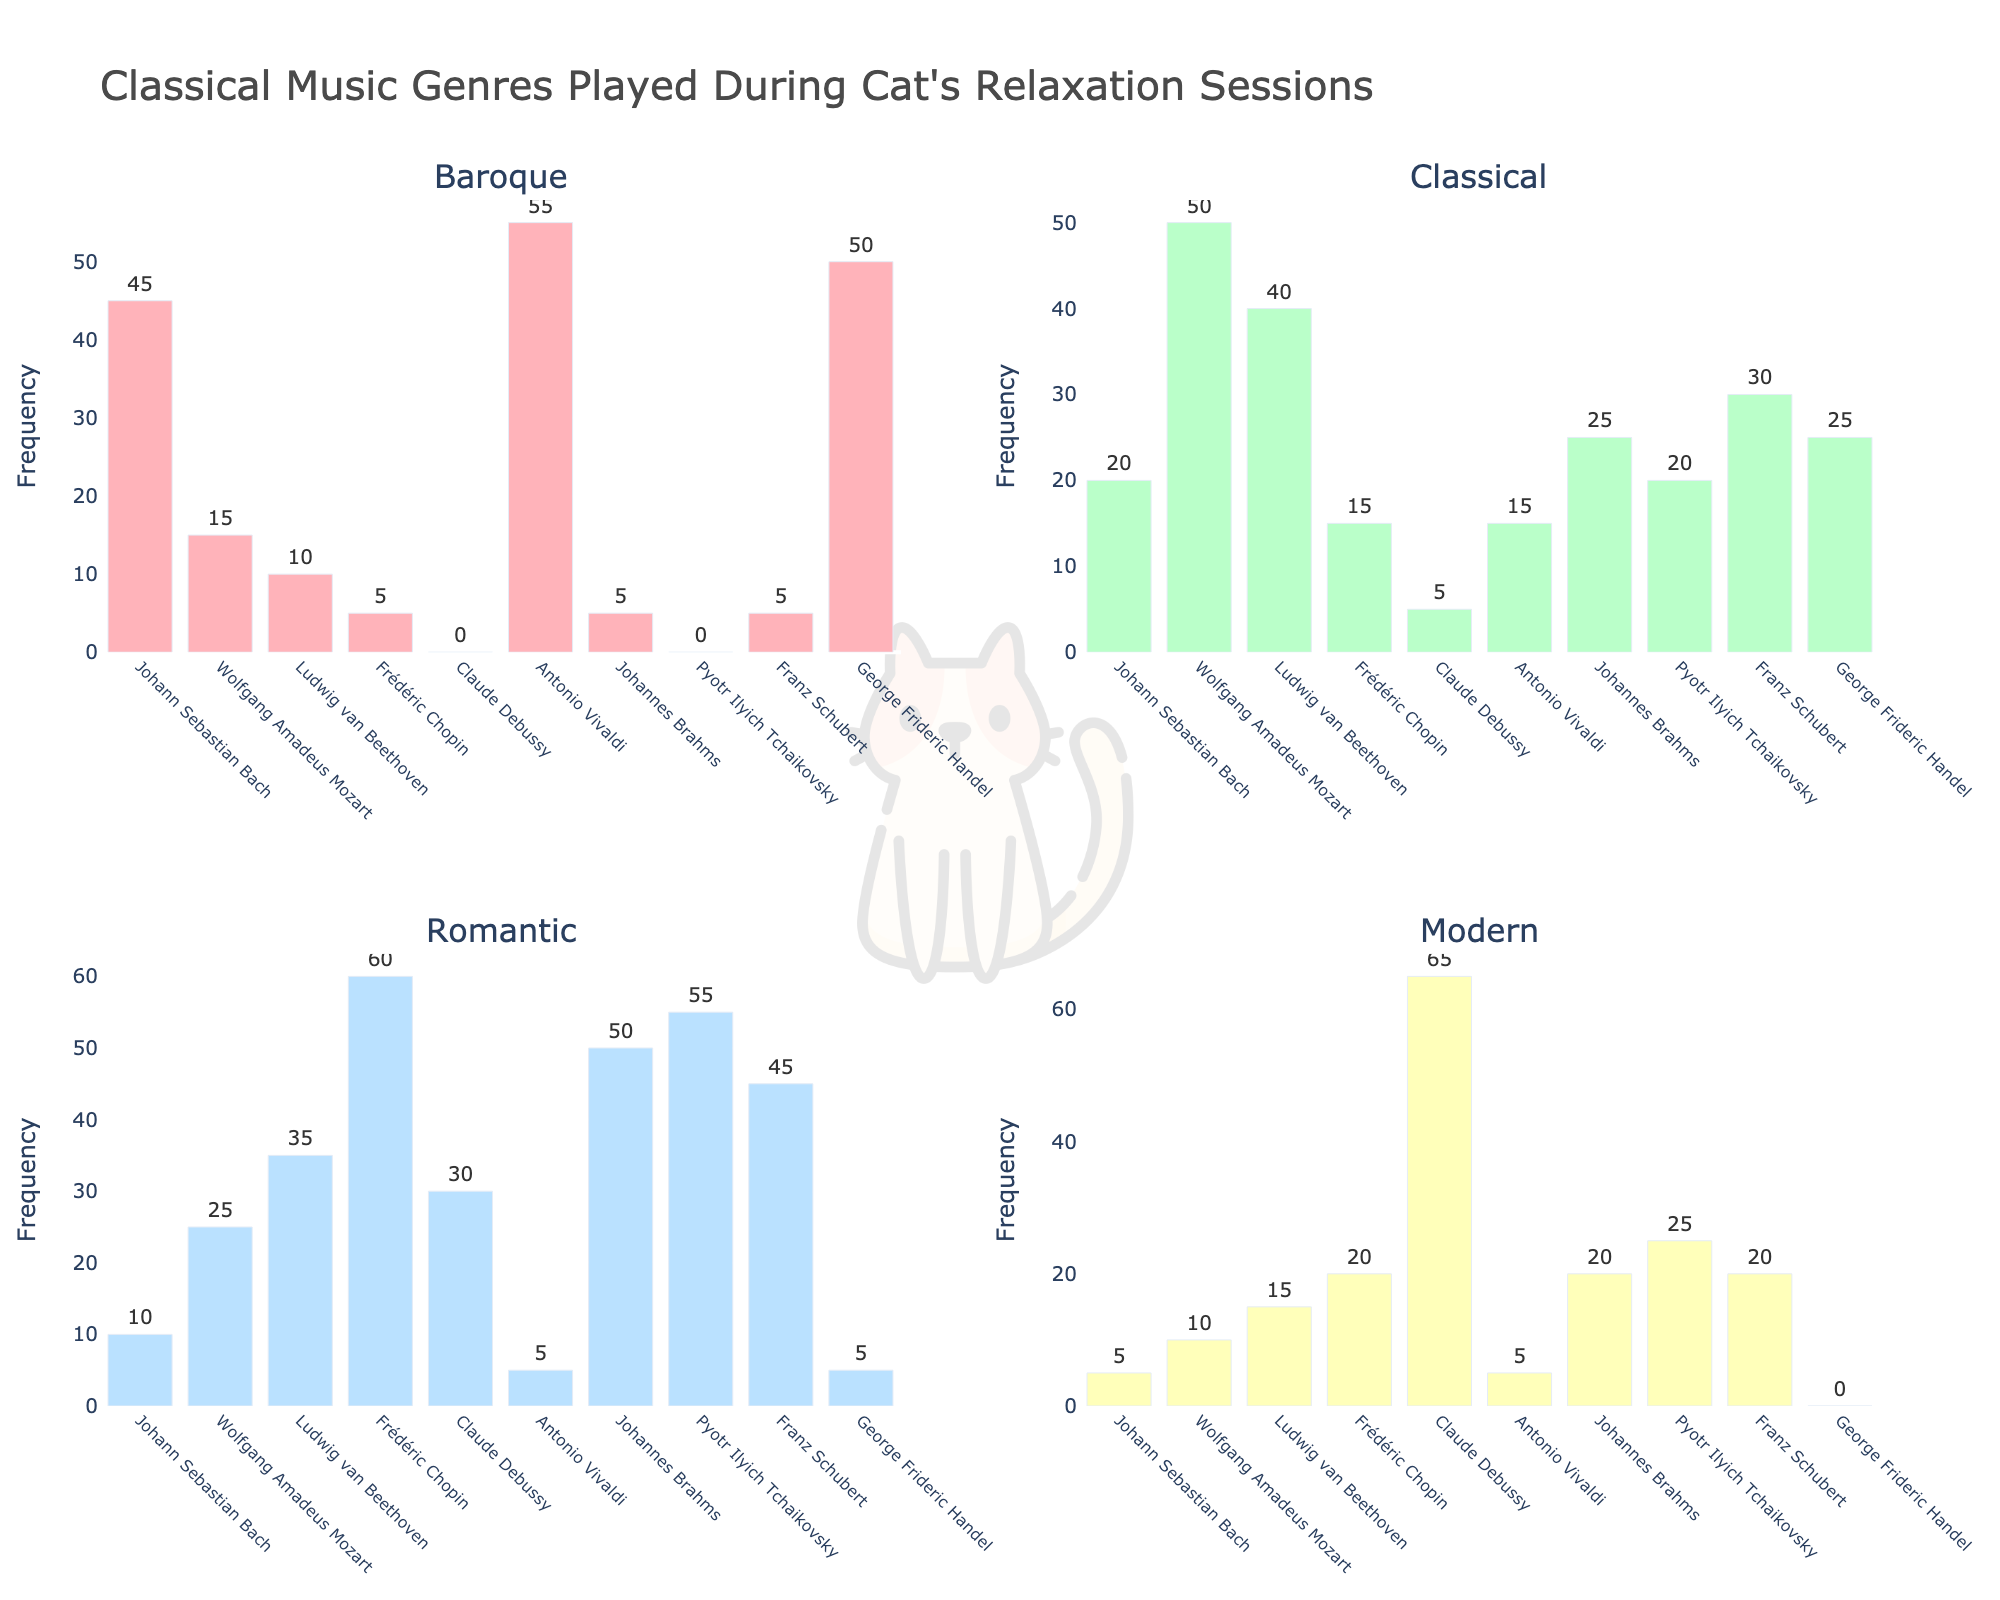Which composer has the highest frequency of Baroque genre played? In the Baroque genre subplot, Antonio Vivaldi has the highest bar, indicating the highest frequency.
Answer: Antonio Vivaldi What is the total frequency of Classical genre played across all composers? Summing the frequencies for the Classical genre subplot: 20 + 50 + 40 + 15 + 5 + 15 + 25 + 20 + 30 + 25 = 245
Answer: 245 Which genres does Ludwig van Beethoven have a higher frequency than Frédéric Chopin? Comparing the bars of Ludwig van Beethoven and Frédéric Chopin in each subplot: Ludwig van Beethoven has a higher frequency in the Baroque, Classical, and Modern genres.
Answer: Baroque, Classical, Modern Which composer has the lowest frequency of Modern genre played? In the Modern genre subplot, Johann Sebastian Bach and Antonio Vivaldi both have the lowest bar, indicating the lowest frequency.
Answer: Johann Sebastian Bach, Antonio Vivaldi For Pyotr Ilyich Tchaikovsky, how many total frequencies are played in the Romantic and Modern genres combined? Adding the frequencies for Pyotr Ilyich Tchaikovsky in the Romantic and Modern subplots: 55 + 25 = 80
Answer: 80 What is the average frequency of Romantic genre played across all composers? Summing the frequencies for the Romantic genre subplot and dividing by the number of composers (10): (10 + 25 + 35 + 60 + 30 + 5 + 50 + 55 + 45 + 5) / 10 = 32
Answer: 32 How many composers have a frequency of 0 for the Baroque genre? Observing the Baroque genre subplot, Pyotr Ilyich Tchaikovsky and Claude Debussy both have a frequency of 0, so there are 2 composers.
Answer: 2 Which genre has the largest frequency variation among composers, and which has the smallest? By visually comparing the ranges of frequencies in each subplot, the Baroque genre has the largest variation (0 to 55), and the Classical genre has the smallest variation (5 to 50).
Answer: Largest: Baroque, Smallest: Classical What is the difference in frequency of the Classical genre played between Johann Sebastian Bach and Wolfgang Amadeus Mozart? Subtracting the frequency of the Classical genre for Johann Sebastian Bach from Wolfgang Amadeus Mozart: 50 - 20 = 30
Answer: 30 